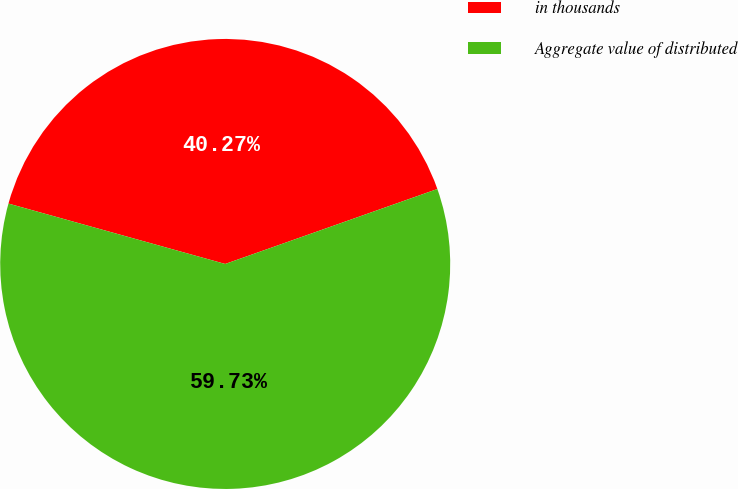Convert chart. <chart><loc_0><loc_0><loc_500><loc_500><pie_chart><fcel>in thousands<fcel>Aggregate value of distributed<nl><fcel>40.27%<fcel>59.73%<nl></chart> 